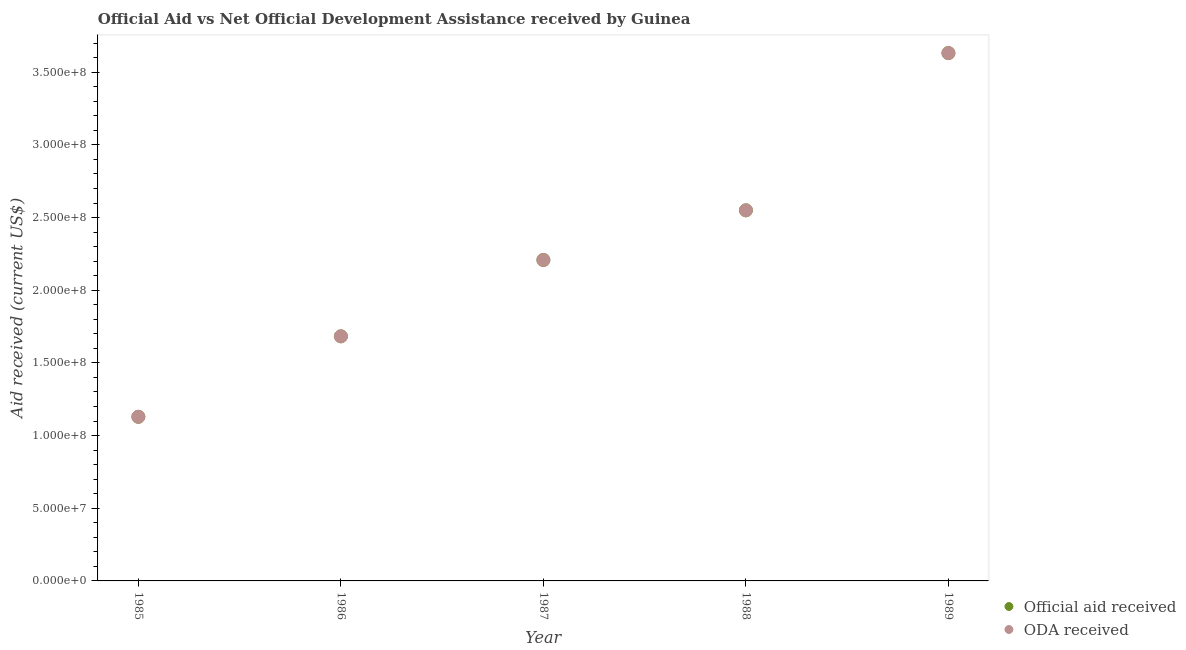How many different coloured dotlines are there?
Your answer should be compact. 2. Is the number of dotlines equal to the number of legend labels?
Provide a succinct answer. Yes. What is the oda received in 1986?
Offer a terse response. 1.68e+08. Across all years, what is the maximum oda received?
Ensure brevity in your answer.  3.63e+08. Across all years, what is the minimum oda received?
Make the answer very short. 1.13e+08. In which year was the official aid received minimum?
Provide a short and direct response. 1985. What is the total official aid received in the graph?
Ensure brevity in your answer.  1.12e+09. What is the difference between the official aid received in 1988 and that in 1989?
Your answer should be very brief. -1.08e+08. What is the difference between the oda received in 1985 and the official aid received in 1986?
Make the answer very short. -5.54e+07. What is the average oda received per year?
Offer a terse response. 2.24e+08. In how many years, is the oda received greater than 110000000 US$?
Offer a terse response. 5. What is the ratio of the official aid received in 1985 to that in 1989?
Ensure brevity in your answer.  0.31. Is the official aid received in 1985 less than that in 1989?
Your response must be concise. Yes. What is the difference between the highest and the second highest official aid received?
Ensure brevity in your answer.  1.08e+08. What is the difference between the highest and the lowest official aid received?
Make the answer very short. 2.50e+08. Does the oda received monotonically increase over the years?
Give a very brief answer. Yes. Is the official aid received strictly less than the oda received over the years?
Your answer should be compact. No. How many dotlines are there?
Your answer should be very brief. 2. Are the values on the major ticks of Y-axis written in scientific E-notation?
Provide a succinct answer. Yes. Does the graph contain any zero values?
Make the answer very short. No. Does the graph contain grids?
Keep it short and to the point. No. How many legend labels are there?
Make the answer very short. 2. How are the legend labels stacked?
Give a very brief answer. Vertical. What is the title of the graph?
Provide a succinct answer. Official Aid vs Net Official Development Assistance received by Guinea . What is the label or title of the X-axis?
Your answer should be compact. Year. What is the label or title of the Y-axis?
Provide a short and direct response. Aid received (current US$). What is the Aid received (current US$) in Official aid received in 1985?
Provide a succinct answer. 1.13e+08. What is the Aid received (current US$) in ODA received in 1985?
Give a very brief answer. 1.13e+08. What is the Aid received (current US$) of Official aid received in 1986?
Your answer should be very brief. 1.68e+08. What is the Aid received (current US$) of ODA received in 1986?
Keep it short and to the point. 1.68e+08. What is the Aid received (current US$) in Official aid received in 1987?
Ensure brevity in your answer.  2.21e+08. What is the Aid received (current US$) in ODA received in 1987?
Give a very brief answer. 2.21e+08. What is the Aid received (current US$) of Official aid received in 1988?
Provide a short and direct response. 2.55e+08. What is the Aid received (current US$) in ODA received in 1988?
Make the answer very short. 2.55e+08. What is the Aid received (current US$) in Official aid received in 1989?
Your answer should be very brief. 3.63e+08. What is the Aid received (current US$) in ODA received in 1989?
Your answer should be very brief. 3.63e+08. Across all years, what is the maximum Aid received (current US$) in Official aid received?
Ensure brevity in your answer.  3.63e+08. Across all years, what is the maximum Aid received (current US$) of ODA received?
Keep it short and to the point. 3.63e+08. Across all years, what is the minimum Aid received (current US$) in Official aid received?
Give a very brief answer. 1.13e+08. Across all years, what is the minimum Aid received (current US$) of ODA received?
Ensure brevity in your answer.  1.13e+08. What is the total Aid received (current US$) of Official aid received in the graph?
Your response must be concise. 1.12e+09. What is the total Aid received (current US$) in ODA received in the graph?
Offer a terse response. 1.12e+09. What is the difference between the Aid received (current US$) of Official aid received in 1985 and that in 1986?
Provide a short and direct response. -5.54e+07. What is the difference between the Aid received (current US$) in ODA received in 1985 and that in 1986?
Your answer should be very brief. -5.54e+07. What is the difference between the Aid received (current US$) of Official aid received in 1985 and that in 1987?
Keep it short and to the point. -1.08e+08. What is the difference between the Aid received (current US$) in ODA received in 1985 and that in 1987?
Keep it short and to the point. -1.08e+08. What is the difference between the Aid received (current US$) in Official aid received in 1985 and that in 1988?
Ensure brevity in your answer.  -1.42e+08. What is the difference between the Aid received (current US$) of ODA received in 1985 and that in 1988?
Offer a terse response. -1.42e+08. What is the difference between the Aid received (current US$) in Official aid received in 1985 and that in 1989?
Give a very brief answer. -2.50e+08. What is the difference between the Aid received (current US$) in ODA received in 1985 and that in 1989?
Your answer should be very brief. -2.50e+08. What is the difference between the Aid received (current US$) in Official aid received in 1986 and that in 1987?
Give a very brief answer. -5.25e+07. What is the difference between the Aid received (current US$) in ODA received in 1986 and that in 1987?
Your response must be concise. -5.25e+07. What is the difference between the Aid received (current US$) of Official aid received in 1986 and that in 1988?
Your answer should be compact. -8.67e+07. What is the difference between the Aid received (current US$) of ODA received in 1986 and that in 1988?
Keep it short and to the point. -8.67e+07. What is the difference between the Aid received (current US$) of Official aid received in 1986 and that in 1989?
Keep it short and to the point. -1.95e+08. What is the difference between the Aid received (current US$) in ODA received in 1986 and that in 1989?
Make the answer very short. -1.95e+08. What is the difference between the Aid received (current US$) of Official aid received in 1987 and that in 1988?
Keep it short and to the point. -3.42e+07. What is the difference between the Aid received (current US$) of ODA received in 1987 and that in 1988?
Make the answer very short. -3.42e+07. What is the difference between the Aid received (current US$) in Official aid received in 1987 and that in 1989?
Offer a terse response. -1.42e+08. What is the difference between the Aid received (current US$) of ODA received in 1987 and that in 1989?
Ensure brevity in your answer.  -1.42e+08. What is the difference between the Aid received (current US$) of Official aid received in 1988 and that in 1989?
Give a very brief answer. -1.08e+08. What is the difference between the Aid received (current US$) in ODA received in 1988 and that in 1989?
Provide a short and direct response. -1.08e+08. What is the difference between the Aid received (current US$) in Official aid received in 1985 and the Aid received (current US$) in ODA received in 1986?
Give a very brief answer. -5.54e+07. What is the difference between the Aid received (current US$) of Official aid received in 1985 and the Aid received (current US$) of ODA received in 1987?
Offer a very short reply. -1.08e+08. What is the difference between the Aid received (current US$) in Official aid received in 1985 and the Aid received (current US$) in ODA received in 1988?
Keep it short and to the point. -1.42e+08. What is the difference between the Aid received (current US$) in Official aid received in 1985 and the Aid received (current US$) in ODA received in 1989?
Your answer should be compact. -2.50e+08. What is the difference between the Aid received (current US$) of Official aid received in 1986 and the Aid received (current US$) of ODA received in 1987?
Offer a very short reply. -5.25e+07. What is the difference between the Aid received (current US$) in Official aid received in 1986 and the Aid received (current US$) in ODA received in 1988?
Your response must be concise. -8.67e+07. What is the difference between the Aid received (current US$) of Official aid received in 1986 and the Aid received (current US$) of ODA received in 1989?
Provide a succinct answer. -1.95e+08. What is the difference between the Aid received (current US$) of Official aid received in 1987 and the Aid received (current US$) of ODA received in 1988?
Ensure brevity in your answer.  -3.42e+07. What is the difference between the Aid received (current US$) in Official aid received in 1987 and the Aid received (current US$) in ODA received in 1989?
Your response must be concise. -1.42e+08. What is the difference between the Aid received (current US$) of Official aid received in 1988 and the Aid received (current US$) of ODA received in 1989?
Provide a succinct answer. -1.08e+08. What is the average Aid received (current US$) in Official aid received per year?
Ensure brevity in your answer.  2.24e+08. What is the average Aid received (current US$) in ODA received per year?
Your answer should be very brief. 2.24e+08. In the year 1986, what is the difference between the Aid received (current US$) of Official aid received and Aid received (current US$) of ODA received?
Keep it short and to the point. 0. In the year 1988, what is the difference between the Aid received (current US$) of Official aid received and Aid received (current US$) of ODA received?
Your answer should be compact. 0. In the year 1989, what is the difference between the Aid received (current US$) in Official aid received and Aid received (current US$) in ODA received?
Keep it short and to the point. 0. What is the ratio of the Aid received (current US$) in Official aid received in 1985 to that in 1986?
Offer a terse response. 0.67. What is the ratio of the Aid received (current US$) of ODA received in 1985 to that in 1986?
Make the answer very short. 0.67. What is the ratio of the Aid received (current US$) in Official aid received in 1985 to that in 1987?
Offer a terse response. 0.51. What is the ratio of the Aid received (current US$) in ODA received in 1985 to that in 1987?
Offer a very short reply. 0.51. What is the ratio of the Aid received (current US$) in Official aid received in 1985 to that in 1988?
Offer a terse response. 0.44. What is the ratio of the Aid received (current US$) in ODA received in 1985 to that in 1988?
Give a very brief answer. 0.44. What is the ratio of the Aid received (current US$) of Official aid received in 1985 to that in 1989?
Make the answer very short. 0.31. What is the ratio of the Aid received (current US$) in ODA received in 1985 to that in 1989?
Offer a terse response. 0.31. What is the ratio of the Aid received (current US$) in Official aid received in 1986 to that in 1987?
Give a very brief answer. 0.76. What is the ratio of the Aid received (current US$) in ODA received in 1986 to that in 1987?
Ensure brevity in your answer.  0.76. What is the ratio of the Aid received (current US$) in Official aid received in 1986 to that in 1988?
Your response must be concise. 0.66. What is the ratio of the Aid received (current US$) of ODA received in 1986 to that in 1988?
Provide a succinct answer. 0.66. What is the ratio of the Aid received (current US$) in Official aid received in 1986 to that in 1989?
Provide a short and direct response. 0.46. What is the ratio of the Aid received (current US$) of ODA received in 1986 to that in 1989?
Provide a short and direct response. 0.46. What is the ratio of the Aid received (current US$) in Official aid received in 1987 to that in 1988?
Your response must be concise. 0.87. What is the ratio of the Aid received (current US$) of ODA received in 1987 to that in 1988?
Make the answer very short. 0.87. What is the ratio of the Aid received (current US$) in Official aid received in 1987 to that in 1989?
Offer a very short reply. 0.61. What is the ratio of the Aid received (current US$) in ODA received in 1987 to that in 1989?
Offer a very short reply. 0.61. What is the ratio of the Aid received (current US$) of Official aid received in 1988 to that in 1989?
Make the answer very short. 0.7. What is the ratio of the Aid received (current US$) in ODA received in 1988 to that in 1989?
Offer a terse response. 0.7. What is the difference between the highest and the second highest Aid received (current US$) in Official aid received?
Offer a very short reply. 1.08e+08. What is the difference between the highest and the second highest Aid received (current US$) of ODA received?
Your answer should be compact. 1.08e+08. What is the difference between the highest and the lowest Aid received (current US$) of Official aid received?
Keep it short and to the point. 2.50e+08. What is the difference between the highest and the lowest Aid received (current US$) in ODA received?
Ensure brevity in your answer.  2.50e+08. 